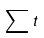Convert formula to latex. <formula><loc_0><loc_0><loc_500><loc_500>\sum { t }</formula> 